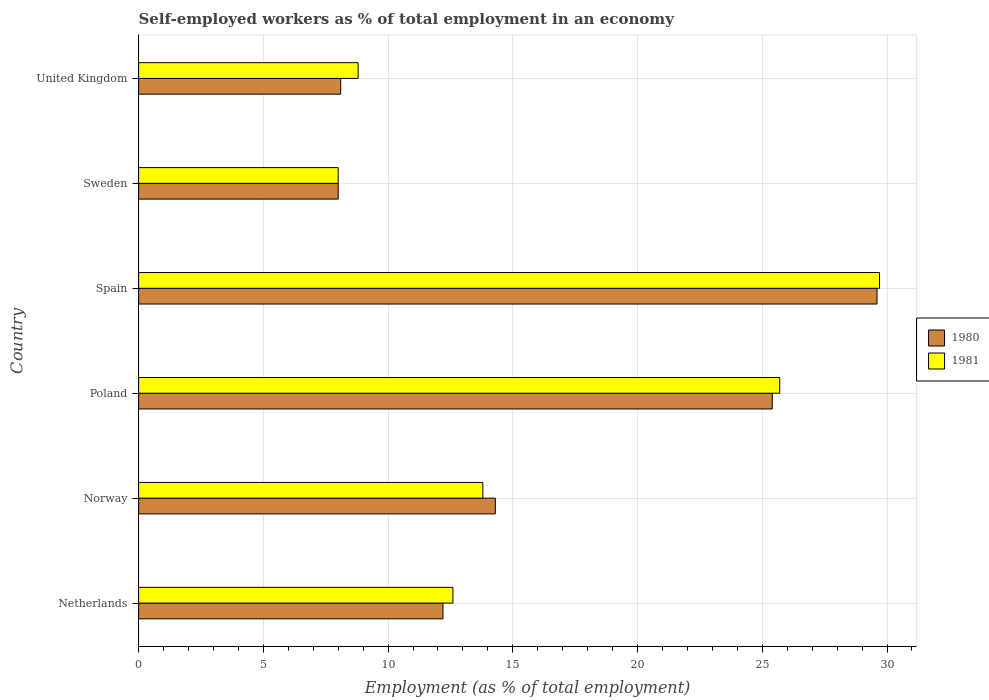How many groups of bars are there?
Your answer should be very brief. 6. Are the number of bars per tick equal to the number of legend labels?
Provide a short and direct response. Yes. Are the number of bars on each tick of the Y-axis equal?
Offer a very short reply. Yes. What is the label of the 1st group of bars from the top?
Your answer should be compact. United Kingdom. What is the percentage of self-employed workers in 1981 in Spain?
Offer a very short reply. 29.7. Across all countries, what is the maximum percentage of self-employed workers in 1981?
Ensure brevity in your answer.  29.7. Across all countries, what is the minimum percentage of self-employed workers in 1981?
Your answer should be compact. 8. In which country was the percentage of self-employed workers in 1980 maximum?
Ensure brevity in your answer.  Spain. What is the total percentage of self-employed workers in 1981 in the graph?
Provide a succinct answer. 98.6. What is the difference between the percentage of self-employed workers in 1980 in Netherlands and that in United Kingdom?
Your answer should be compact. 4.1. What is the difference between the percentage of self-employed workers in 1980 in Spain and the percentage of self-employed workers in 1981 in United Kingdom?
Your response must be concise. 20.8. What is the average percentage of self-employed workers in 1981 per country?
Give a very brief answer. 16.43. What is the difference between the percentage of self-employed workers in 1980 and percentage of self-employed workers in 1981 in Norway?
Your answer should be compact. 0.5. In how many countries, is the percentage of self-employed workers in 1981 greater than 28 %?
Provide a short and direct response. 1. What is the ratio of the percentage of self-employed workers in 1980 in Poland to that in United Kingdom?
Keep it short and to the point. 3.14. Is the percentage of self-employed workers in 1980 in Spain less than that in Sweden?
Keep it short and to the point. No. Is the difference between the percentage of self-employed workers in 1980 in Netherlands and Poland greater than the difference between the percentage of self-employed workers in 1981 in Netherlands and Poland?
Ensure brevity in your answer.  No. What is the difference between the highest and the lowest percentage of self-employed workers in 1981?
Make the answer very short. 21.7. Is the sum of the percentage of self-employed workers in 1981 in Netherlands and Spain greater than the maximum percentage of self-employed workers in 1980 across all countries?
Offer a very short reply. Yes. What does the 2nd bar from the bottom in United Kingdom represents?
Your answer should be compact. 1981. How many bars are there?
Provide a succinct answer. 12. How many countries are there in the graph?
Provide a succinct answer. 6. Does the graph contain any zero values?
Your response must be concise. No. Does the graph contain grids?
Provide a short and direct response. Yes. Where does the legend appear in the graph?
Offer a very short reply. Center right. How many legend labels are there?
Offer a terse response. 2. What is the title of the graph?
Offer a terse response. Self-employed workers as % of total employment in an economy. What is the label or title of the X-axis?
Keep it short and to the point. Employment (as % of total employment). What is the Employment (as % of total employment) in 1980 in Netherlands?
Your response must be concise. 12.2. What is the Employment (as % of total employment) in 1981 in Netherlands?
Offer a terse response. 12.6. What is the Employment (as % of total employment) in 1980 in Norway?
Provide a short and direct response. 14.3. What is the Employment (as % of total employment) of 1981 in Norway?
Make the answer very short. 13.8. What is the Employment (as % of total employment) of 1980 in Poland?
Provide a succinct answer. 25.4. What is the Employment (as % of total employment) of 1981 in Poland?
Provide a succinct answer. 25.7. What is the Employment (as % of total employment) in 1980 in Spain?
Your answer should be compact. 29.6. What is the Employment (as % of total employment) in 1981 in Spain?
Your answer should be compact. 29.7. What is the Employment (as % of total employment) in 1980 in Sweden?
Keep it short and to the point. 8. What is the Employment (as % of total employment) in 1981 in Sweden?
Your answer should be compact. 8. What is the Employment (as % of total employment) of 1980 in United Kingdom?
Give a very brief answer. 8.1. What is the Employment (as % of total employment) in 1981 in United Kingdom?
Ensure brevity in your answer.  8.8. Across all countries, what is the maximum Employment (as % of total employment) of 1980?
Provide a succinct answer. 29.6. Across all countries, what is the maximum Employment (as % of total employment) of 1981?
Provide a succinct answer. 29.7. Across all countries, what is the minimum Employment (as % of total employment) in 1980?
Provide a short and direct response. 8. Across all countries, what is the minimum Employment (as % of total employment) in 1981?
Provide a short and direct response. 8. What is the total Employment (as % of total employment) in 1980 in the graph?
Your answer should be compact. 97.6. What is the total Employment (as % of total employment) in 1981 in the graph?
Offer a very short reply. 98.6. What is the difference between the Employment (as % of total employment) of 1980 in Netherlands and that in Norway?
Keep it short and to the point. -2.1. What is the difference between the Employment (as % of total employment) in 1980 in Netherlands and that in Poland?
Provide a short and direct response. -13.2. What is the difference between the Employment (as % of total employment) of 1981 in Netherlands and that in Poland?
Ensure brevity in your answer.  -13.1. What is the difference between the Employment (as % of total employment) of 1980 in Netherlands and that in Spain?
Give a very brief answer. -17.4. What is the difference between the Employment (as % of total employment) of 1981 in Netherlands and that in Spain?
Give a very brief answer. -17.1. What is the difference between the Employment (as % of total employment) in 1980 in Netherlands and that in Sweden?
Your answer should be compact. 4.2. What is the difference between the Employment (as % of total employment) in 1980 in Netherlands and that in United Kingdom?
Provide a succinct answer. 4.1. What is the difference between the Employment (as % of total employment) of 1980 in Norway and that in Spain?
Your answer should be compact. -15.3. What is the difference between the Employment (as % of total employment) of 1981 in Norway and that in Spain?
Keep it short and to the point. -15.9. What is the difference between the Employment (as % of total employment) in 1980 in Norway and that in United Kingdom?
Make the answer very short. 6.2. What is the difference between the Employment (as % of total employment) of 1981 in Norway and that in United Kingdom?
Make the answer very short. 5. What is the difference between the Employment (as % of total employment) of 1981 in Poland and that in Spain?
Your response must be concise. -4. What is the difference between the Employment (as % of total employment) in 1980 in Poland and that in Sweden?
Your answer should be very brief. 17.4. What is the difference between the Employment (as % of total employment) in 1981 in Poland and that in Sweden?
Provide a succinct answer. 17.7. What is the difference between the Employment (as % of total employment) in 1980 in Poland and that in United Kingdom?
Your response must be concise. 17.3. What is the difference between the Employment (as % of total employment) of 1980 in Spain and that in Sweden?
Offer a very short reply. 21.6. What is the difference between the Employment (as % of total employment) in 1981 in Spain and that in Sweden?
Offer a terse response. 21.7. What is the difference between the Employment (as % of total employment) of 1981 in Spain and that in United Kingdom?
Your answer should be very brief. 20.9. What is the difference between the Employment (as % of total employment) of 1980 in Netherlands and the Employment (as % of total employment) of 1981 in Norway?
Keep it short and to the point. -1.6. What is the difference between the Employment (as % of total employment) of 1980 in Netherlands and the Employment (as % of total employment) of 1981 in Poland?
Your answer should be very brief. -13.5. What is the difference between the Employment (as % of total employment) of 1980 in Netherlands and the Employment (as % of total employment) of 1981 in Spain?
Give a very brief answer. -17.5. What is the difference between the Employment (as % of total employment) in 1980 in Netherlands and the Employment (as % of total employment) in 1981 in Sweden?
Ensure brevity in your answer.  4.2. What is the difference between the Employment (as % of total employment) in 1980 in Netherlands and the Employment (as % of total employment) in 1981 in United Kingdom?
Your answer should be very brief. 3.4. What is the difference between the Employment (as % of total employment) in 1980 in Norway and the Employment (as % of total employment) in 1981 in Poland?
Provide a succinct answer. -11.4. What is the difference between the Employment (as % of total employment) of 1980 in Norway and the Employment (as % of total employment) of 1981 in Spain?
Offer a very short reply. -15.4. What is the difference between the Employment (as % of total employment) in 1980 in Norway and the Employment (as % of total employment) in 1981 in United Kingdom?
Offer a very short reply. 5.5. What is the difference between the Employment (as % of total employment) of 1980 in Poland and the Employment (as % of total employment) of 1981 in Spain?
Make the answer very short. -4.3. What is the difference between the Employment (as % of total employment) of 1980 in Poland and the Employment (as % of total employment) of 1981 in United Kingdom?
Give a very brief answer. 16.6. What is the difference between the Employment (as % of total employment) in 1980 in Spain and the Employment (as % of total employment) in 1981 in Sweden?
Provide a short and direct response. 21.6. What is the difference between the Employment (as % of total employment) of 1980 in Spain and the Employment (as % of total employment) of 1981 in United Kingdom?
Give a very brief answer. 20.8. What is the average Employment (as % of total employment) in 1980 per country?
Provide a succinct answer. 16.27. What is the average Employment (as % of total employment) in 1981 per country?
Offer a terse response. 16.43. What is the difference between the Employment (as % of total employment) of 1980 and Employment (as % of total employment) of 1981 in Netherlands?
Your answer should be very brief. -0.4. What is the difference between the Employment (as % of total employment) in 1980 and Employment (as % of total employment) in 1981 in United Kingdom?
Make the answer very short. -0.7. What is the ratio of the Employment (as % of total employment) of 1980 in Netherlands to that in Norway?
Your answer should be compact. 0.85. What is the ratio of the Employment (as % of total employment) in 1981 in Netherlands to that in Norway?
Your answer should be very brief. 0.91. What is the ratio of the Employment (as % of total employment) in 1980 in Netherlands to that in Poland?
Provide a short and direct response. 0.48. What is the ratio of the Employment (as % of total employment) of 1981 in Netherlands to that in Poland?
Keep it short and to the point. 0.49. What is the ratio of the Employment (as % of total employment) in 1980 in Netherlands to that in Spain?
Keep it short and to the point. 0.41. What is the ratio of the Employment (as % of total employment) in 1981 in Netherlands to that in Spain?
Give a very brief answer. 0.42. What is the ratio of the Employment (as % of total employment) of 1980 in Netherlands to that in Sweden?
Ensure brevity in your answer.  1.52. What is the ratio of the Employment (as % of total employment) of 1981 in Netherlands to that in Sweden?
Make the answer very short. 1.57. What is the ratio of the Employment (as % of total employment) of 1980 in Netherlands to that in United Kingdom?
Give a very brief answer. 1.51. What is the ratio of the Employment (as % of total employment) in 1981 in Netherlands to that in United Kingdom?
Offer a terse response. 1.43. What is the ratio of the Employment (as % of total employment) of 1980 in Norway to that in Poland?
Provide a short and direct response. 0.56. What is the ratio of the Employment (as % of total employment) of 1981 in Norway to that in Poland?
Provide a short and direct response. 0.54. What is the ratio of the Employment (as % of total employment) in 1980 in Norway to that in Spain?
Ensure brevity in your answer.  0.48. What is the ratio of the Employment (as % of total employment) in 1981 in Norway to that in Spain?
Offer a terse response. 0.46. What is the ratio of the Employment (as % of total employment) in 1980 in Norway to that in Sweden?
Ensure brevity in your answer.  1.79. What is the ratio of the Employment (as % of total employment) in 1981 in Norway to that in Sweden?
Provide a short and direct response. 1.73. What is the ratio of the Employment (as % of total employment) of 1980 in Norway to that in United Kingdom?
Your response must be concise. 1.77. What is the ratio of the Employment (as % of total employment) of 1981 in Norway to that in United Kingdom?
Your response must be concise. 1.57. What is the ratio of the Employment (as % of total employment) of 1980 in Poland to that in Spain?
Keep it short and to the point. 0.86. What is the ratio of the Employment (as % of total employment) in 1981 in Poland to that in Spain?
Give a very brief answer. 0.87. What is the ratio of the Employment (as % of total employment) of 1980 in Poland to that in Sweden?
Offer a terse response. 3.17. What is the ratio of the Employment (as % of total employment) in 1981 in Poland to that in Sweden?
Make the answer very short. 3.21. What is the ratio of the Employment (as % of total employment) of 1980 in Poland to that in United Kingdom?
Ensure brevity in your answer.  3.14. What is the ratio of the Employment (as % of total employment) of 1981 in Poland to that in United Kingdom?
Offer a terse response. 2.92. What is the ratio of the Employment (as % of total employment) of 1980 in Spain to that in Sweden?
Offer a very short reply. 3.7. What is the ratio of the Employment (as % of total employment) in 1981 in Spain to that in Sweden?
Keep it short and to the point. 3.71. What is the ratio of the Employment (as % of total employment) of 1980 in Spain to that in United Kingdom?
Your answer should be very brief. 3.65. What is the ratio of the Employment (as % of total employment) in 1981 in Spain to that in United Kingdom?
Your response must be concise. 3.38. What is the difference between the highest and the second highest Employment (as % of total employment) in 1980?
Keep it short and to the point. 4.2. What is the difference between the highest and the second highest Employment (as % of total employment) of 1981?
Give a very brief answer. 4. What is the difference between the highest and the lowest Employment (as % of total employment) of 1980?
Ensure brevity in your answer.  21.6. What is the difference between the highest and the lowest Employment (as % of total employment) in 1981?
Keep it short and to the point. 21.7. 